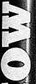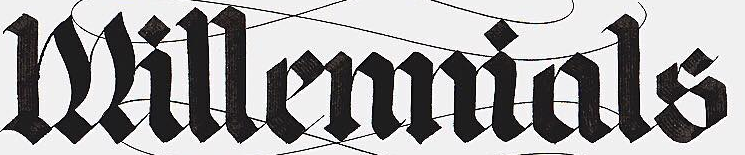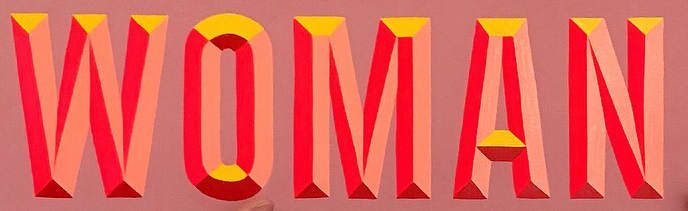What text appears in these images from left to right, separated by a semicolon? MO; Millemmials; WOMAN 